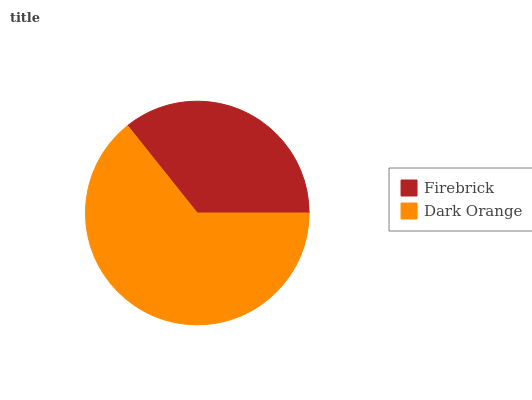Is Firebrick the minimum?
Answer yes or no. Yes. Is Dark Orange the maximum?
Answer yes or no. Yes. Is Dark Orange the minimum?
Answer yes or no. No. Is Dark Orange greater than Firebrick?
Answer yes or no. Yes. Is Firebrick less than Dark Orange?
Answer yes or no. Yes. Is Firebrick greater than Dark Orange?
Answer yes or no. No. Is Dark Orange less than Firebrick?
Answer yes or no. No. Is Dark Orange the high median?
Answer yes or no. Yes. Is Firebrick the low median?
Answer yes or no. Yes. Is Firebrick the high median?
Answer yes or no. No. Is Dark Orange the low median?
Answer yes or no. No. 